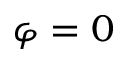Convert formula to latex. <formula><loc_0><loc_0><loc_500><loc_500>\varphi = 0</formula> 